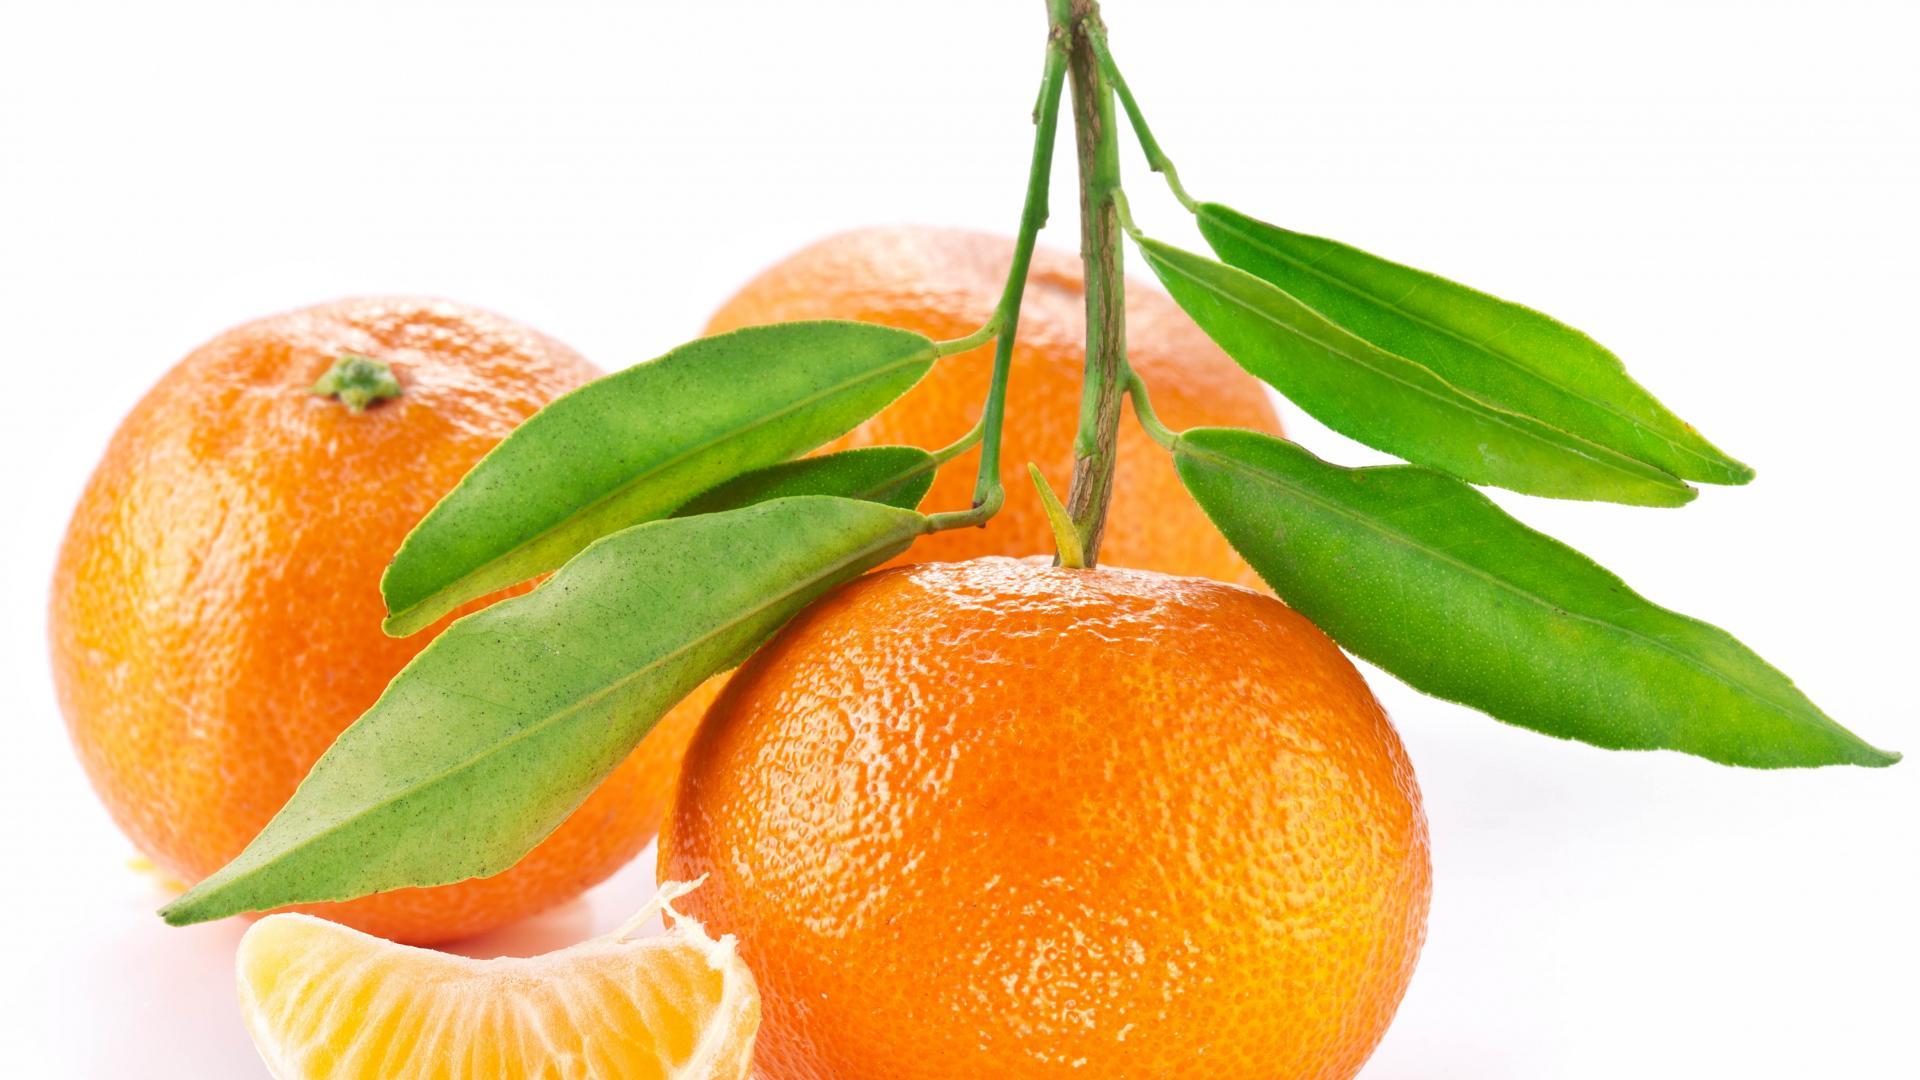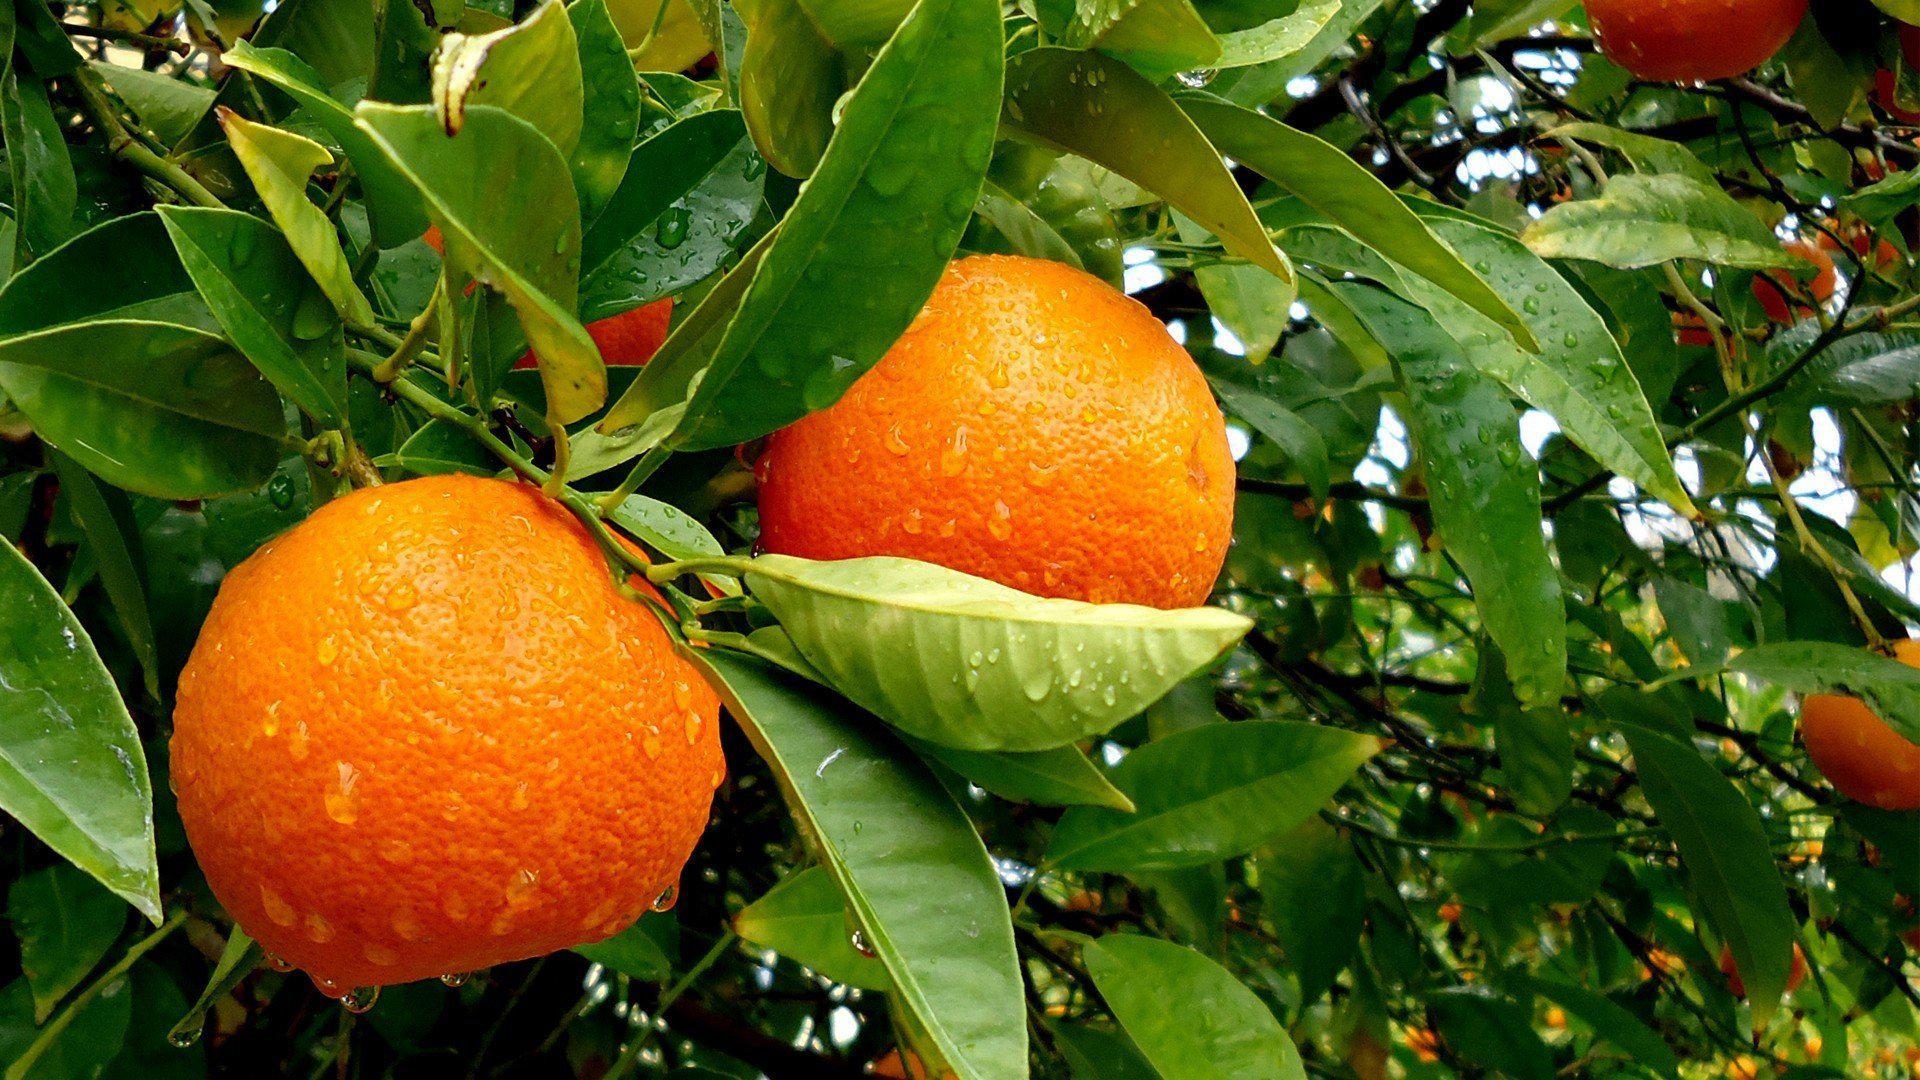The first image is the image on the left, the second image is the image on the right. For the images shown, is this caption "The right image features orange fruits growing in a green-leafed tree, and the left image includes a whole orange with green leaves attached." true? Answer yes or no. Yes. The first image is the image on the left, the second image is the image on the right. For the images displayed, is the sentence "The image on the left shows both cut fruit and uncut fruit." factually correct? Answer yes or no. No. 